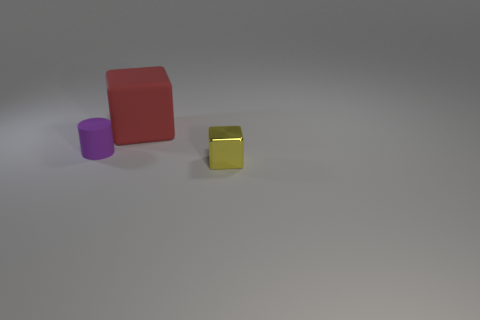Is the number of yellow metal cubes less than the number of large cyan objects? Yes, there is only one yellow metal cube, while there are no large cyan objects present at all. 